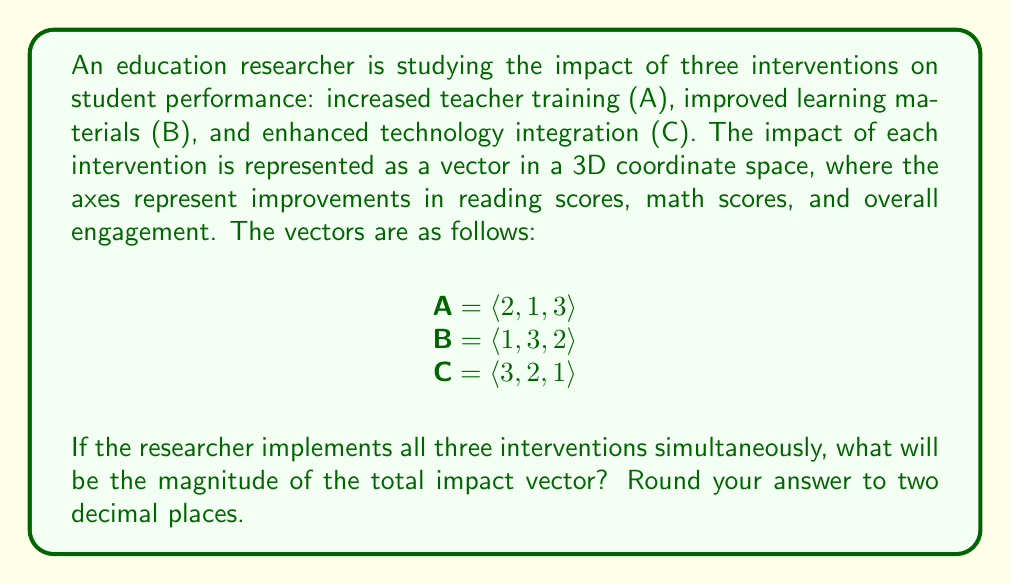Give your solution to this math problem. To solve this problem, we need to follow these steps:

1. Find the sum of the three intervention vectors to get the total impact vector.
2. Calculate the magnitude of the resulting vector.

Step 1: Sum of the vectors
The total impact vector T is the sum of vectors A, B, and C:

T = A + B + C
  = $\langle 2, 1, 3 \rangle + \langle 1, 3, 2 \rangle + \langle 3, 2, 1 \rangle$
  = $\langle 2+1+3, 1+3+2, 3+2+1 \rangle$
  = $\langle 6, 6, 6 \rangle$

Step 2: Magnitude of the total impact vector
The magnitude of a vector $\vec{v} = \langle x, y, z \rangle$ is given by the formula:

$\|\vec{v}\| = \sqrt{x^2 + y^2 + z^2}$

For our total impact vector T = $\langle 6, 6, 6 \rangle$:

$\|T\| = \sqrt{6^2 + 6^2 + 6^2}$
      = $\sqrt{36 + 36 + 36}$
      = $\sqrt{108}$
      = $6\sqrt{3}$
      ≈ 10.39 (rounded to two decimal places)

This result represents the overall magnitude of the combined interventions' impact on student performance across reading scores, math scores, and overall engagement.
Answer: 10.39 